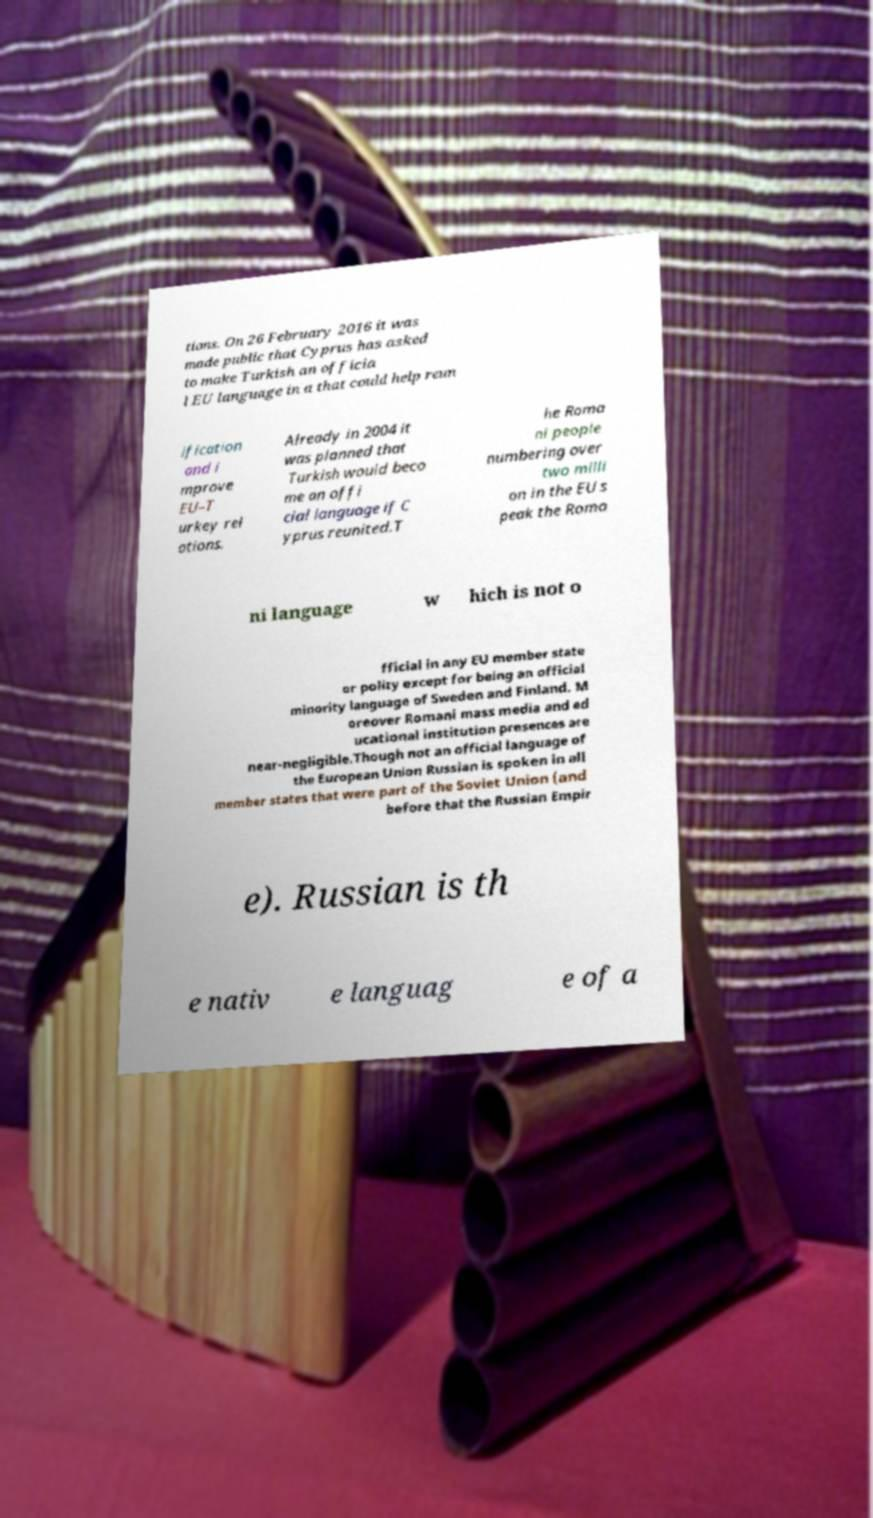Can you read and provide the text displayed in the image?This photo seems to have some interesting text. Can you extract and type it out for me? tions. On 26 February 2016 it was made public that Cyprus has asked to make Turkish an officia l EU language in a that could help reun ification and i mprove EU–T urkey rel ations. Already in 2004 it was planned that Turkish would beco me an offi cial language if C yprus reunited.T he Roma ni people numbering over two milli on in the EU s peak the Roma ni language w hich is not o fficial in any EU member state or polity except for being an official minority language of Sweden and Finland. M oreover Romani mass media and ed ucational institution presences are near-negligible.Though not an official language of the European Union Russian is spoken in all member states that were part of the Soviet Union (and before that the Russian Empir e). Russian is th e nativ e languag e of a 